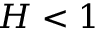<formula> <loc_0><loc_0><loc_500><loc_500>H < 1</formula> 